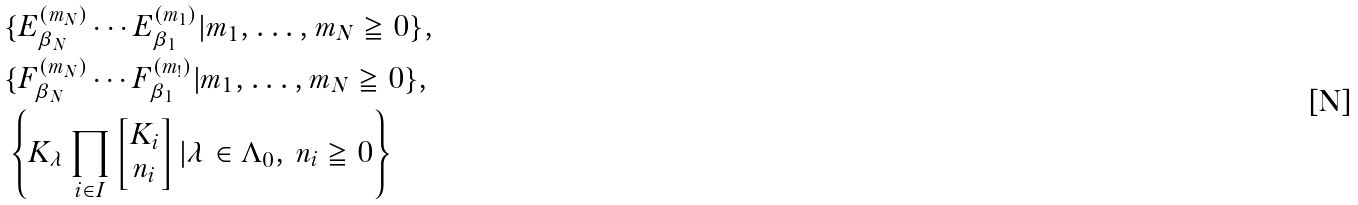<formula> <loc_0><loc_0><loc_500><loc_500>& \{ E _ { \beta _ { N } } ^ { ( m _ { N } ) } \cdots E _ { \beta _ { 1 } } ^ { ( m _ { 1 } ) } | m _ { 1 } , \dots , m _ { N } \geqq 0 \} , \\ & \{ F _ { \beta _ { N } } ^ { ( m _ { N } ) } \cdots F _ { \beta _ { 1 } } ^ { ( m _ { ! } ) } | m _ { 1 } , \dots , m _ { N } \geqq 0 \} , \\ & \left \{ K _ { \lambda } \prod _ { i \in I } \begin{bmatrix} { K _ { i } } \\ { n _ { i } } \end{bmatrix} | \lambda \in \Lambda _ { 0 } , \, n _ { i } \geqq 0 \right \}</formula> 